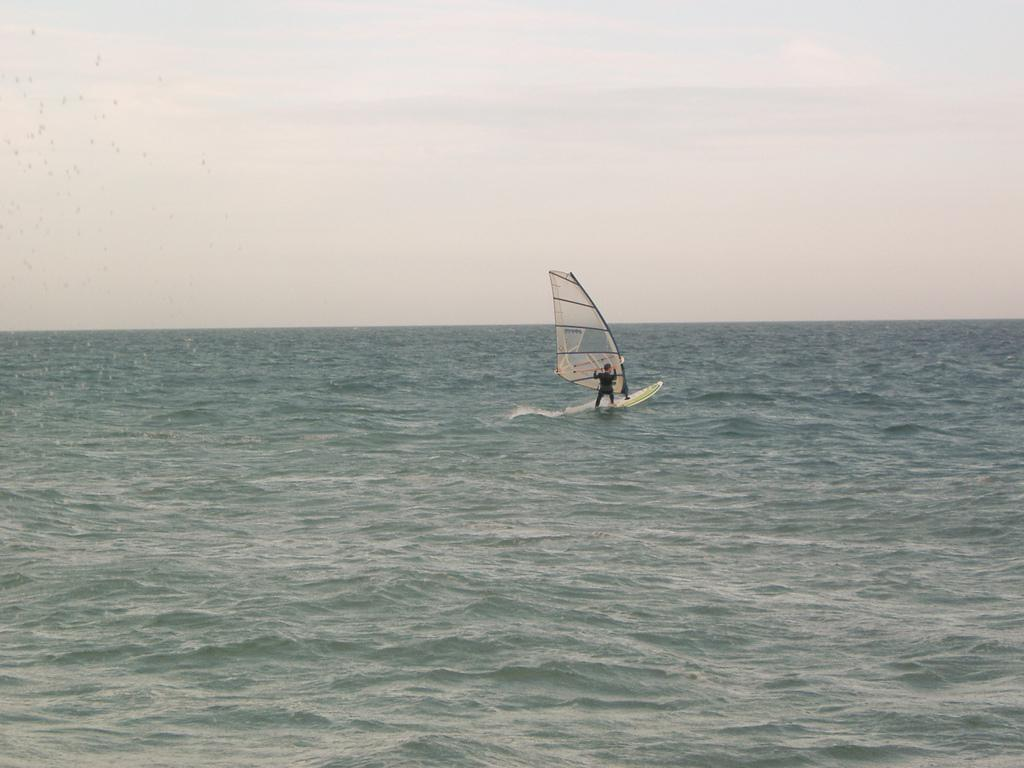What is the main subject of the image? There is a boat in the image. Is there anyone on the boat? Yes, a person is on the boat. What can be seen around the boat? There is water visible in the image. What is visible in the background of the image? The sky is visible in the background of the image. Can you see any magic happening on the boat in the image? There is no magic present in the image; it features a boat with a person on it and the surrounding water and sky. Are there any bats flying around the boat in the image? There are no bats visible in the image; it only features a boat, a person, water, and the sky. 